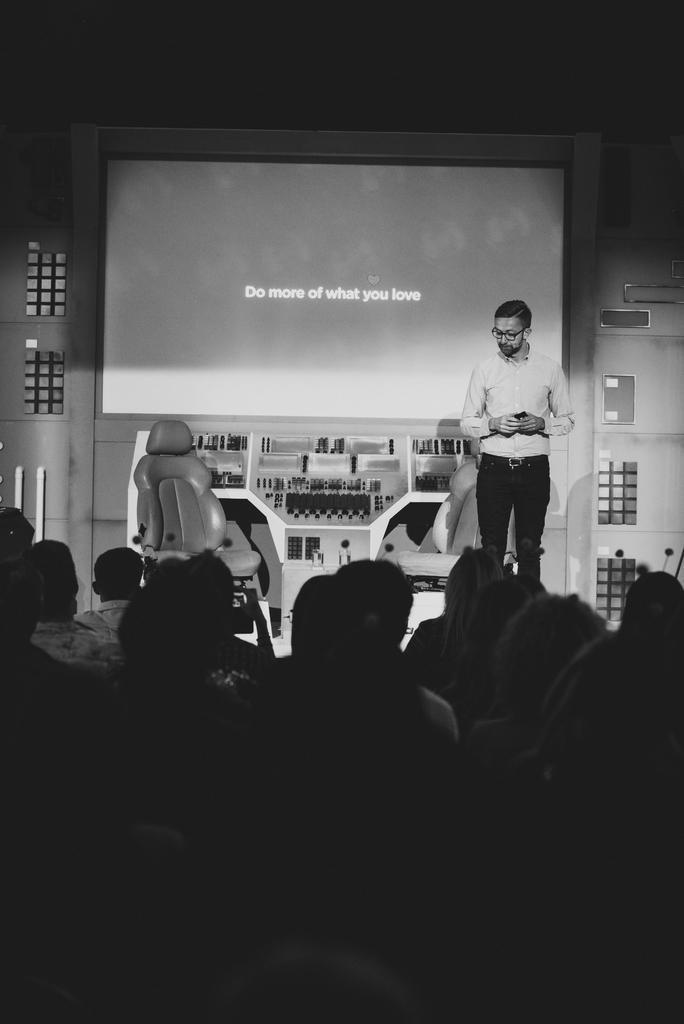Please provide a concise description of this image. This image is taken indoors. This image is a black and white image. At the bottom of the image a few people are sitting on the chairs. In the background there is a wall and there is a screen with a text on it. There are a few shelves with a few things. There are two empty chairs. In the middle of the image a man is standing and he is holding an object in his hands. 